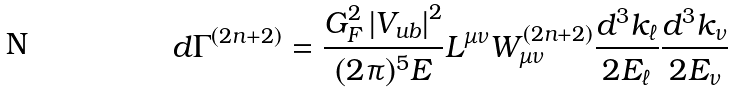<formula> <loc_0><loc_0><loc_500><loc_500>d \Gamma ^ { ( 2 n + 2 ) } = \frac { G _ { F } ^ { 2 } \left | V _ { u b } \right | ^ { 2 } } { ( 2 \pi ) ^ { 5 } E } L ^ { \mu \nu } W _ { \mu \nu } ^ { ( 2 n + 2 ) } \frac { d ^ { 3 } k _ { \ell } } { 2 E _ { \ell } } \frac { d ^ { 3 } k _ { \nu } } { 2 E _ { \nu } }</formula> 